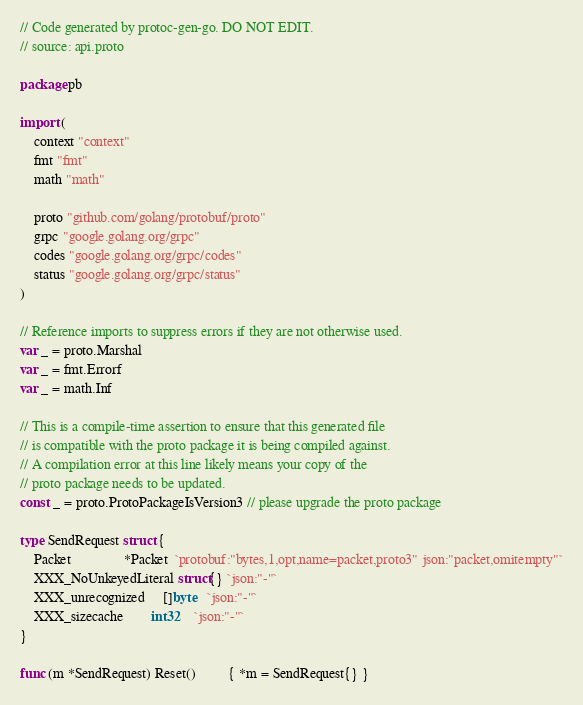<code> <loc_0><loc_0><loc_500><loc_500><_Go_>// Code generated by protoc-gen-go. DO NOT EDIT.
// source: api.proto

package pb

import (
	context "context"
	fmt "fmt"
	math "math"

	proto "github.com/golang/protobuf/proto"
	grpc "google.golang.org/grpc"
	codes "google.golang.org/grpc/codes"
	status "google.golang.org/grpc/status"
)

// Reference imports to suppress errors if they are not otherwise used.
var _ = proto.Marshal
var _ = fmt.Errorf
var _ = math.Inf

// This is a compile-time assertion to ensure that this generated file
// is compatible with the proto package it is being compiled against.
// A compilation error at this line likely means your copy of the
// proto package needs to be updated.
const _ = proto.ProtoPackageIsVersion3 // please upgrade the proto package

type SendRequest struct {
	Packet               *Packet  `protobuf:"bytes,1,opt,name=packet,proto3" json:"packet,omitempty"`
	XXX_NoUnkeyedLiteral struct{} `json:"-"`
	XXX_unrecognized     []byte   `json:"-"`
	XXX_sizecache        int32    `json:"-"`
}

func (m *SendRequest) Reset()         { *m = SendRequest{} }</code> 